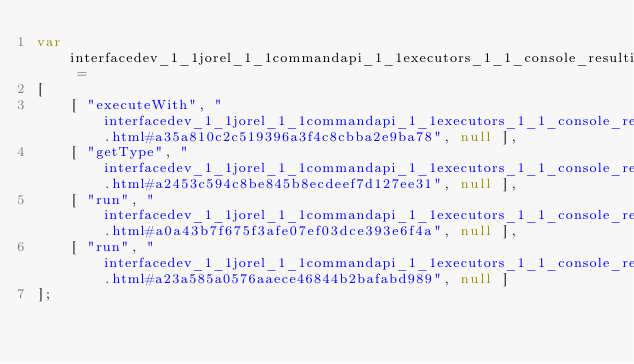Convert code to text. <code><loc_0><loc_0><loc_500><loc_500><_JavaScript_>var interfacedev_1_1jorel_1_1commandapi_1_1executors_1_1_console_resulting_command_executor =
[
    [ "executeWith", "interfacedev_1_1jorel_1_1commandapi_1_1executors_1_1_console_resulting_command_executor.html#a35a810c2c519396a3f4c8cbba2e9ba78", null ],
    [ "getType", "interfacedev_1_1jorel_1_1commandapi_1_1executors_1_1_console_resulting_command_executor.html#a2453c594c8be845b8ecdeef7d127ee31", null ],
    [ "run", "interfacedev_1_1jorel_1_1commandapi_1_1executors_1_1_console_resulting_command_executor.html#a0a43b7f675f3afe07ef03dce393e6f4a", null ],
    [ "run", "interfacedev_1_1jorel_1_1commandapi_1_1executors_1_1_console_resulting_command_executor.html#a23a585a0576aaece46844b2bafabd989", null ]
];</code> 